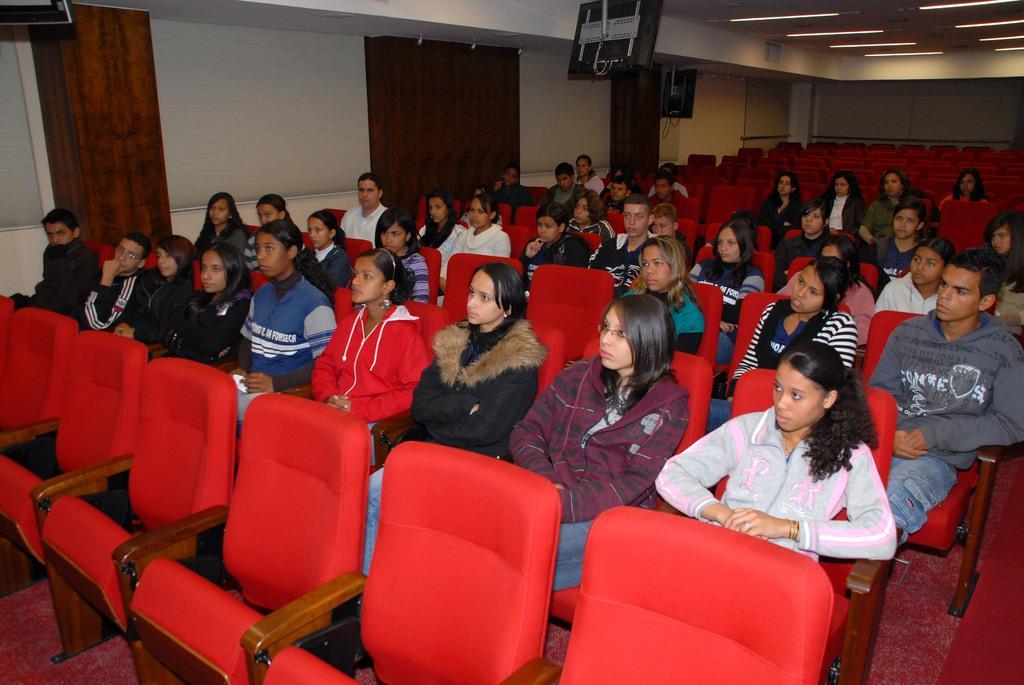Describe this image in one or two sentences. As we can see in the image there is a white color wall, curtains and few people sitting on chairs. 